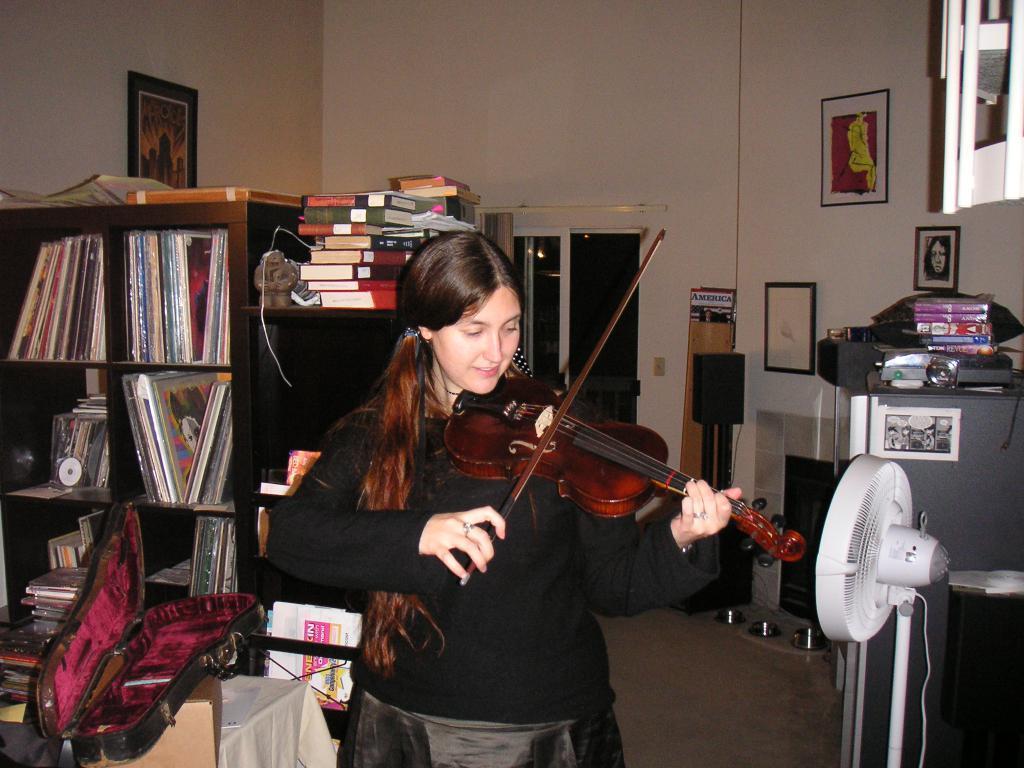Please provide a concise description of this image. In this image in the middle there is a woman she wear black dress she is playing violin her hair is long. On the right there is a fan. On the left there is a table, box, wardrobe, books, photo frame and wall. In the background there is a window and wall. 